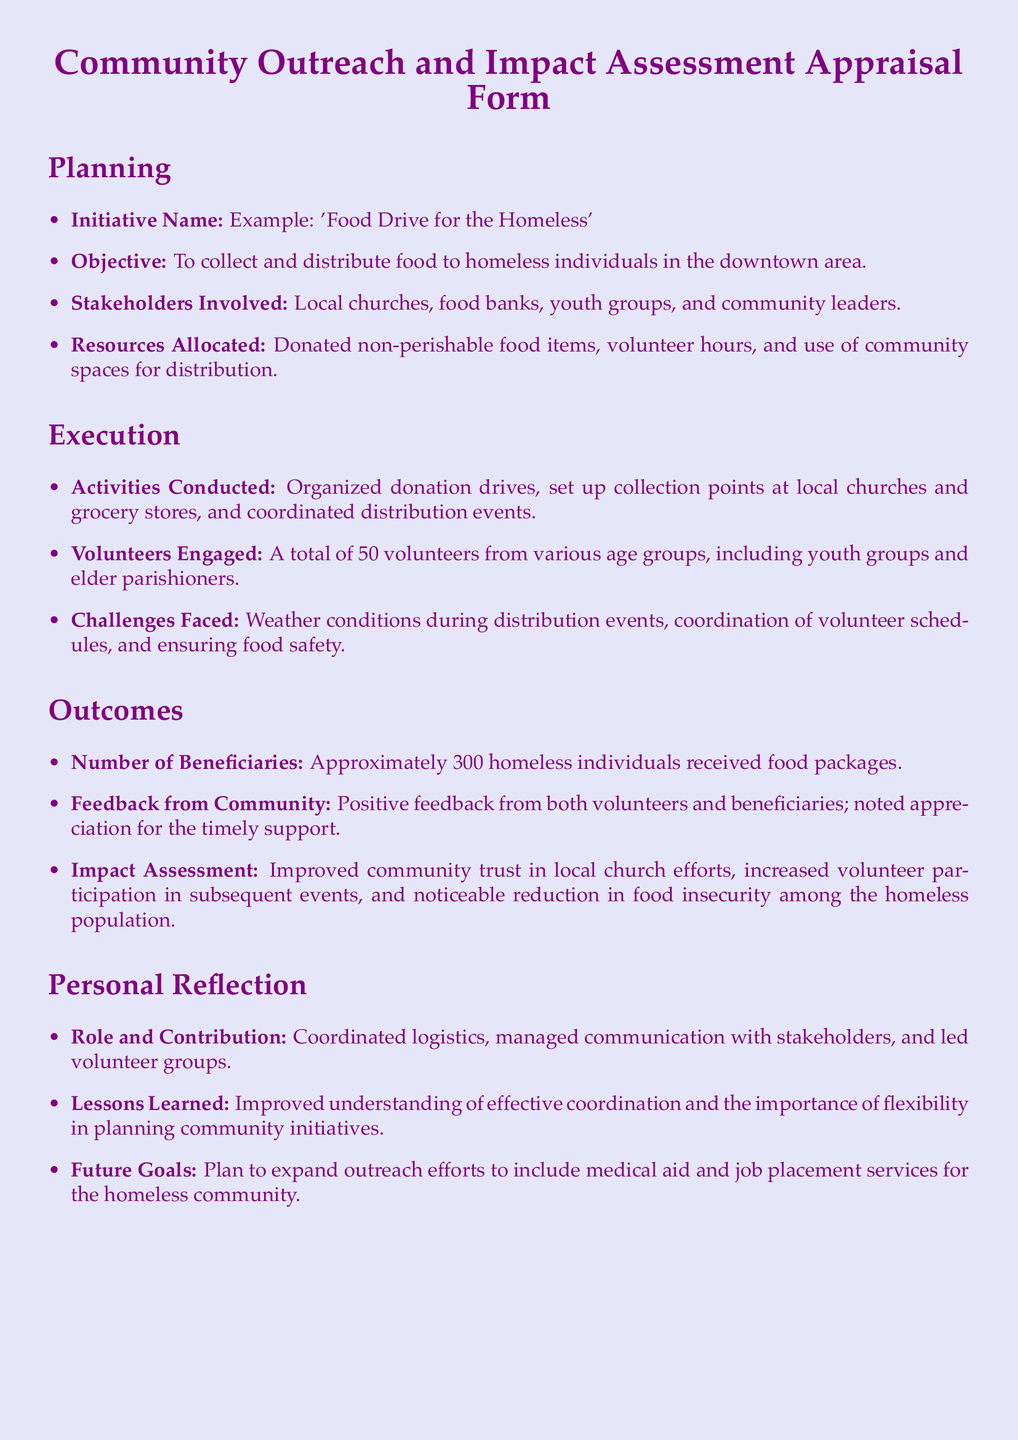What is the initiative name? The initiative name is stated at the beginning of the Planning section.
Answer: 'Food Drive for the Homeless' What was the objective of the initiative? The objective is specified in the Planning section of the document.
Answer: To collect and distribute food to homeless individuals in the downtown area How many volunteers were engaged? The number of volunteers is detailed in the Execution section.
Answer: A total of 50 volunteers What challenges were faced during the initiative? The challenges are outlined in the Execution section of the document.
Answer: Weather conditions during distribution events How many beneficiaries received food packages? The number of beneficiaries is mentioned in the Outcomes section.
Answer: Approximately 300 homeless individuals What type of feedback did the community provide? The feedback from the community is summarized in the Outcomes section.
Answer: Positive feedback from both volunteers and beneficiaries What lesson was learned from this initiative? The lessons learned are described in the Personal Reflection section.
Answer: Improved understanding of effective coordination What future goal was identified for outreach efforts? The future goals for outreach efforts are stated in the Personal Reflection section.
Answer: Plan to expand outreach efforts to include medical aid and job placement services for the homeless community Who coordinated logistics for the initiative? The individual responsible for coordinating logistics is specified in the Personal Reflection section.
Answer: Coordinated logistics, managed communication with stakeholders, and led volunteer groups What stakeholders were involved in the initiative? The stakeholders involved are listed in the Planning section.
Answer: Local churches, food banks, youth groups, and community leaders 